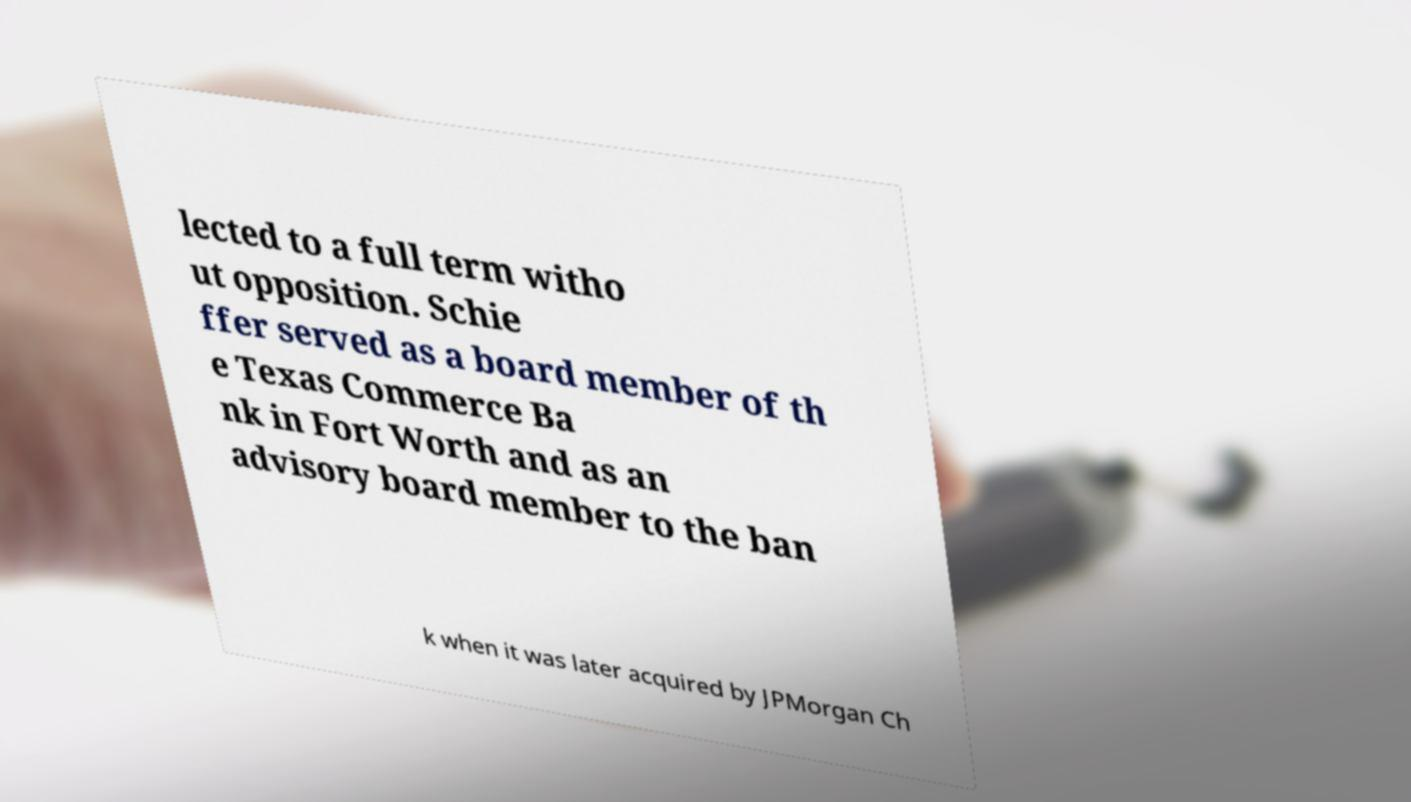I need the written content from this picture converted into text. Can you do that? lected to a full term witho ut opposition. Schie ffer served as a board member of th e Texas Commerce Ba nk in Fort Worth and as an advisory board member to the ban k when it was later acquired by JPMorgan Ch 